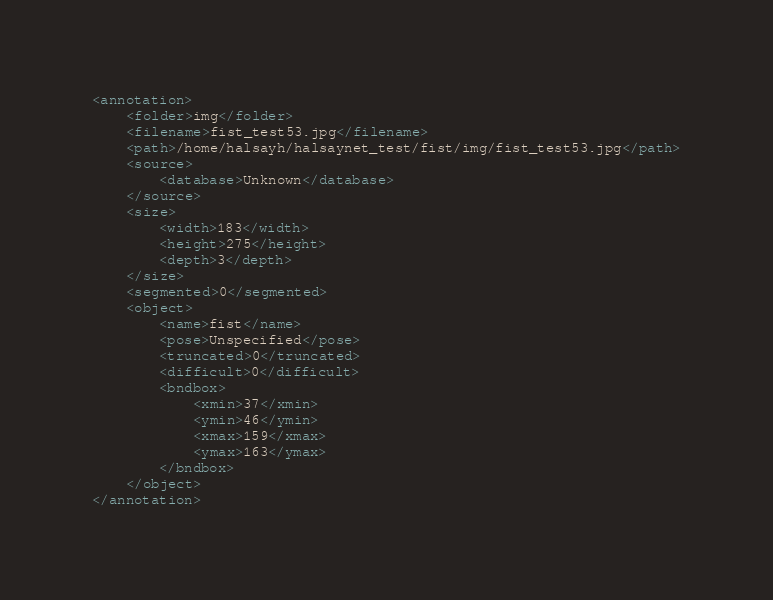Convert code to text. <code><loc_0><loc_0><loc_500><loc_500><_XML_><annotation>
	<folder>img</folder>
	<filename>fist_test53.jpg</filename>
	<path>/home/halsayh/halsaynet_test/fist/img/fist_test53.jpg</path>
	<source>
		<database>Unknown</database>
	</source>
	<size>
		<width>183</width>
		<height>275</height>
		<depth>3</depth>
	</size>
	<segmented>0</segmented>
	<object>
		<name>fist</name>
		<pose>Unspecified</pose>
		<truncated>0</truncated>
		<difficult>0</difficult>
		<bndbox>
			<xmin>37</xmin>
			<ymin>46</ymin>
			<xmax>159</xmax>
			<ymax>163</ymax>
		</bndbox>
	</object>
</annotation>
</code> 